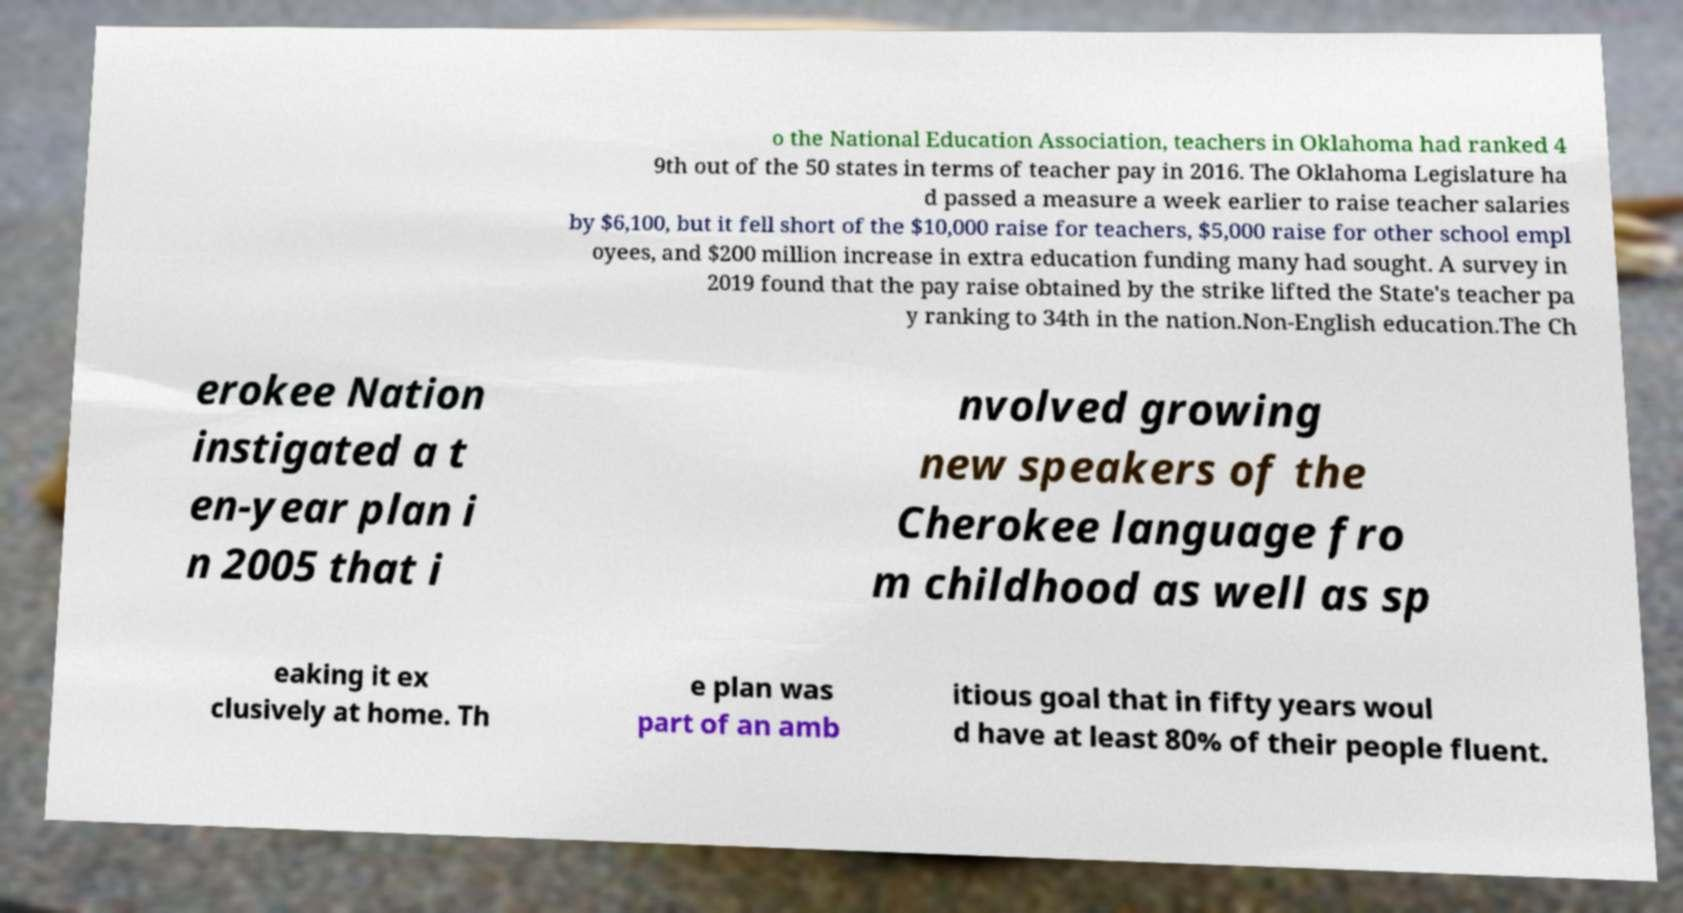There's text embedded in this image that I need extracted. Can you transcribe it verbatim? o the National Education Association, teachers in Oklahoma had ranked 4 9th out of the 50 states in terms of teacher pay in 2016. The Oklahoma Legislature ha d passed a measure a week earlier to raise teacher salaries by $6,100, but it fell short of the $10,000 raise for teachers, $5,000 raise for other school empl oyees, and $200 million increase in extra education funding many had sought. A survey in 2019 found that the pay raise obtained by the strike lifted the State's teacher pa y ranking to 34th in the nation.Non-English education.The Ch erokee Nation instigated a t en-year plan i n 2005 that i nvolved growing new speakers of the Cherokee language fro m childhood as well as sp eaking it ex clusively at home. Th e plan was part of an amb itious goal that in fifty years woul d have at least 80% of their people fluent. 